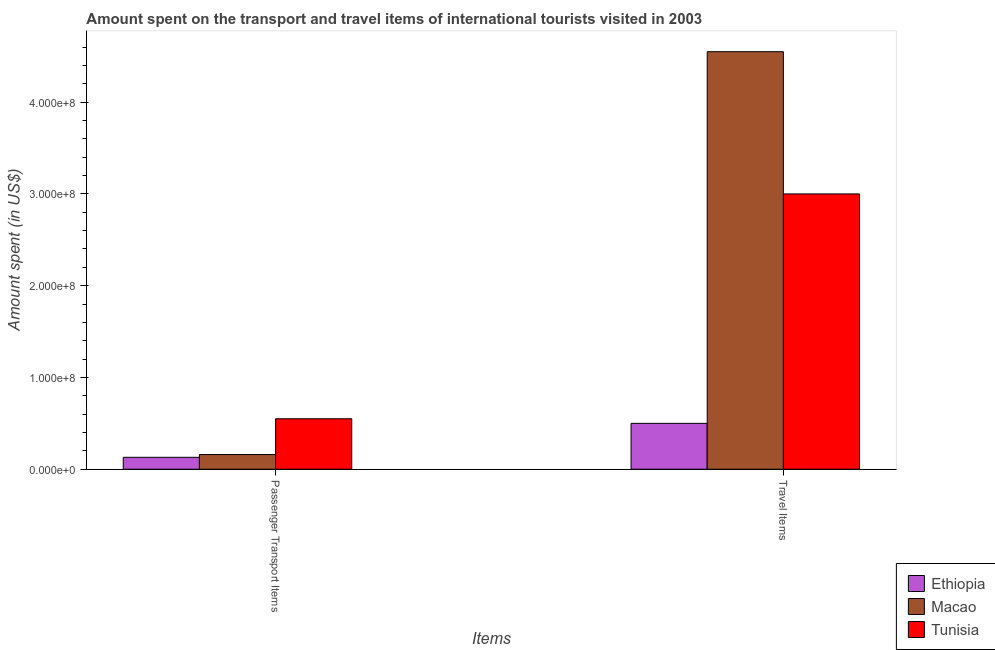How many groups of bars are there?
Offer a terse response. 2. What is the label of the 1st group of bars from the left?
Keep it short and to the point. Passenger Transport Items. What is the amount spent on passenger transport items in Tunisia?
Provide a short and direct response. 5.50e+07. Across all countries, what is the maximum amount spent in travel items?
Keep it short and to the point. 4.55e+08. Across all countries, what is the minimum amount spent in travel items?
Provide a succinct answer. 5.00e+07. In which country was the amount spent in travel items maximum?
Your response must be concise. Macao. In which country was the amount spent on passenger transport items minimum?
Offer a very short reply. Ethiopia. What is the total amount spent in travel items in the graph?
Provide a succinct answer. 8.05e+08. What is the difference between the amount spent on passenger transport items in Ethiopia and that in Tunisia?
Provide a short and direct response. -4.20e+07. What is the difference between the amount spent in travel items in Macao and the amount spent on passenger transport items in Tunisia?
Your response must be concise. 4.00e+08. What is the average amount spent in travel items per country?
Your answer should be very brief. 2.68e+08. What is the difference between the amount spent on passenger transport items and amount spent in travel items in Macao?
Your response must be concise. -4.39e+08. In how many countries, is the amount spent in travel items greater than 400000000 US$?
Give a very brief answer. 1. What does the 1st bar from the left in Passenger Transport Items represents?
Ensure brevity in your answer.  Ethiopia. What does the 3rd bar from the right in Travel Items represents?
Keep it short and to the point. Ethiopia. How many bars are there?
Ensure brevity in your answer.  6. Are all the bars in the graph horizontal?
Keep it short and to the point. No. How many countries are there in the graph?
Your response must be concise. 3. Are the values on the major ticks of Y-axis written in scientific E-notation?
Ensure brevity in your answer.  Yes. How many legend labels are there?
Provide a succinct answer. 3. How are the legend labels stacked?
Offer a very short reply. Vertical. What is the title of the graph?
Your response must be concise. Amount spent on the transport and travel items of international tourists visited in 2003. Does "El Salvador" appear as one of the legend labels in the graph?
Your response must be concise. No. What is the label or title of the X-axis?
Provide a short and direct response. Items. What is the label or title of the Y-axis?
Your answer should be very brief. Amount spent (in US$). What is the Amount spent (in US$) in Ethiopia in Passenger Transport Items?
Your answer should be compact. 1.30e+07. What is the Amount spent (in US$) of Macao in Passenger Transport Items?
Offer a terse response. 1.60e+07. What is the Amount spent (in US$) in Tunisia in Passenger Transport Items?
Offer a very short reply. 5.50e+07. What is the Amount spent (in US$) of Ethiopia in Travel Items?
Offer a very short reply. 5.00e+07. What is the Amount spent (in US$) of Macao in Travel Items?
Give a very brief answer. 4.55e+08. What is the Amount spent (in US$) of Tunisia in Travel Items?
Ensure brevity in your answer.  3.00e+08. Across all Items, what is the maximum Amount spent (in US$) of Ethiopia?
Give a very brief answer. 5.00e+07. Across all Items, what is the maximum Amount spent (in US$) in Macao?
Ensure brevity in your answer.  4.55e+08. Across all Items, what is the maximum Amount spent (in US$) of Tunisia?
Give a very brief answer. 3.00e+08. Across all Items, what is the minimum Amount spent (in US$) of Ethiopia?
Ensure brevity in your answer.  1.30e+07. Across all Items, what is the minimum Amount spent (in US$) in Macao?
Keep it short and to the point. 1.60e+07. Across all Items, what is the minimum Amount spent (in US$) of Tunisia?
Make the answer very short. 5.50e+07. What is the total Amount spent (in US$) in Ethiopia in the graph?
Your response must be concise. 6.30e+07. What is the total Amount spent (in US$) of Macao in the graph?
Make the answer very short. 4.71e+08. What is the total Amount spent (in US$) in Tunisia in the graph?
Ensure brevity in your answer.  3.55e+08. What is the difference between the Amount spent (in US$) of Ethiopia in Passenger Transport Items and that in Travel Items?
Make the answer very short. -3.70e+07. What is the difference between the Amount spent (in US$) in Macao in Passenger Transport Items and that in Travel Items?
Make the answer very short. -4.39e+08. What is the difference between the Amount spent (in US$) of Tunisia in Passenger Transport Items and that in Travel Items?
Give a very brief answer. -2.45e+08. What is the difference between the Amount spent (in US$) of Ethiopia in Passenger Transport Items and the Amount spent (in US$) of Macao in Travel Items?
Offer a terse response. -4.42e+08. What is the difference between the Amount spent (in US$) in Ethiopia in Passenger Transport Items and the Amount spent (in US$) in Tunisia in Travel Items?
Offer a very short reply. -2.87e+08. What is the difference between the Amount spent (in US$) of Macao in Passenger Transport Items and the Amount spent (in US$) of Tunisia in Travel Items?
Provide a succinct answer. -2.84e+08. What is the average Amount spent (in US$) of Ethiopia per Items?
Offer a very short reply. 3.15e+07. What is the average Amount spent (in US$) in Macao per Items?
Offer a very short reply. 2.36e+08. What is the average Amount spent (in US$) in Tunisia per Items?
Provide a short and direct response. 1.78e+08. What is the difference between the Amount spent (in US$) in Ethiopia and Amount spent (in US$) in Tunisia in Passenger Transport Items?
Ensure brevity in your answer.  -4.20e+07. What is the difference between the Amount spent (in US$) of Macao and Amount spent (in US$) of Tunisia in Passenger Transport Items?
Your answer should be very brief. -3.90e+07. What is the difference between the Amount spent (in US$) in Ethiopia and Amount spent (in US$) in Macao in Travel Items?
Keep it short and to the point. -4.05e+08. What is the difference between the Amount spent (in US$) of Ethiopia and Amount spent (in US$) of Tunisia in Travel Items?
Keep it short and to the point. -2.50e+08. What is the difference between the Amount spent (in US$) of Macao and Amount spent (in US$) of Tunisia in Travel Items?
Give a very brief answer. 1.55e+08. What is the ratio of the Amount spent (in US$) of Ethiopia in Passenger Transport Items to that in Travel Items?
Provide a short and direct response. 0.26. What is the ratio of the Amount spent (in US$) of Macao in Passenger Transport Items to that in Travel Items?
Keep it short and to the point. 0.04. What is the ratio of the Amount spent (in US$) in Tunisia in Passenger Transport Items to that in Travel Items?
Make the answer very short. 0.18. What is the difference between the highest and the second highest Amount spent (in US$) in Ethiopia?
Provide a succinct answer. 3.70e+07. What is the difference between the highest and the second highest Amount spent (in US$) in Macao?
Ensure brevity in your answer.  4.39e+08. What is the difference between the highest and the second highest Amount spent (in US$) of Tunisia?
Offer a very short reply. 2.45e+08. What is the difference between the highest and the lowest Amount spent (in US$) of Ethiopia?
Provide a short and direct response. 3.70e+07. What is the difference between the highest and the lowest Amount spent (in US$) of Macao?
Offer a very short reply. 4.39e+08. What is the difference between the highest and the lowest Amount spent (in US$) of Tunisia?
Your answer should be very brief. 2.45e+08. 